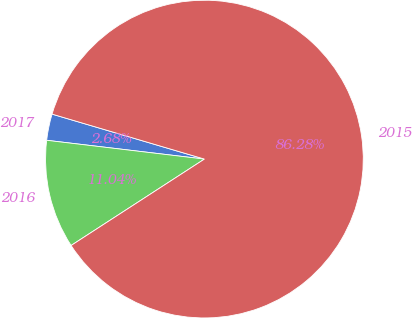<chart> <loc_0><loc_0><loc_500><loc_500><pie_chart><fcel>2017<fcel>2016<fcel>2015<nl><fcel>2.68%<fcel>11.04%<fcel>86.28%<nl></chart> 